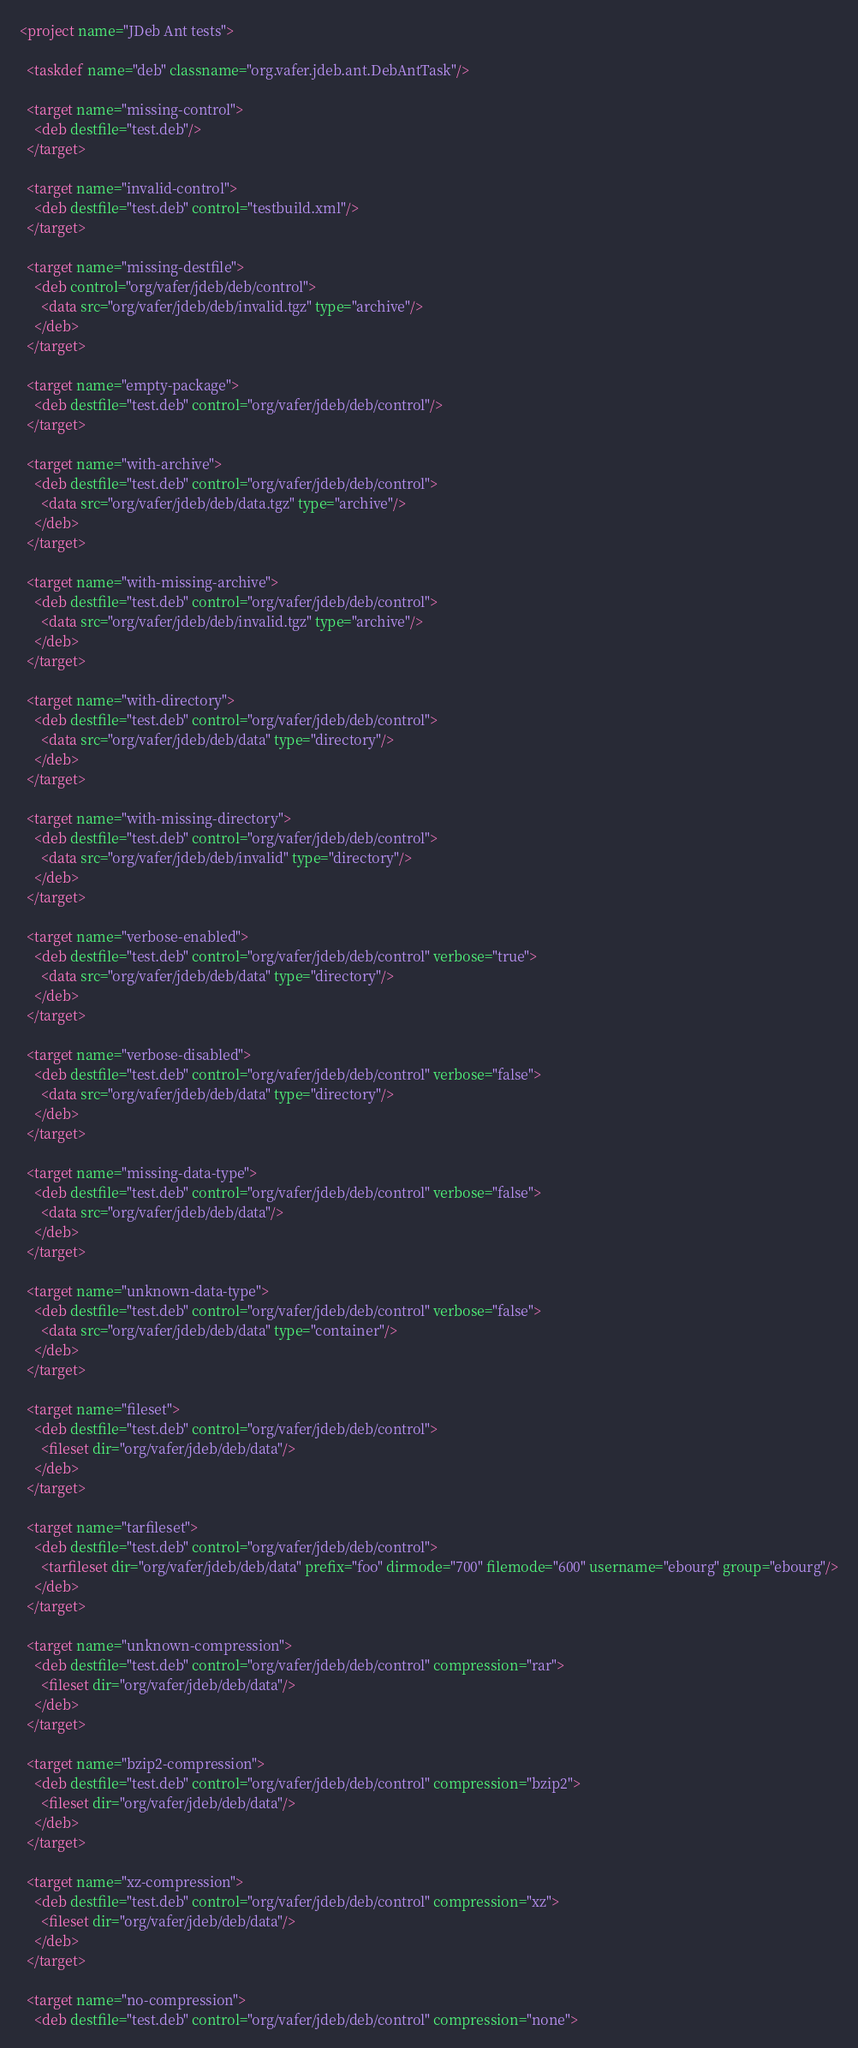Convert code to text. <code><loc_0><loc_0><loc_500><loc_500><_XML_><project name="JDeb Ant tests">

  <taskdef name="deb" classname="org.vafer.jdeb.ant.DebAntTask"/>

  <target name="missing-control">
    <deb destfile="test.deb"/>
  </target>

  <target name="invalid-control">
    <deb destfile="test.deb" control="testbuild.xml"/>
  </target>

  <target name="missing-destfile">
    <deb control="org/vafer/jdeb/deb/control">
      <data src="org/vafer/jdeb/deb/invalid.tgz" type="archive"/>
    </deb>
  </target>

  <target name="empty-package">
    <deb destfile="test.deb" control="org/vafer/jdeb/deb/control"/>
  </target>

  <target name="with-archive">
    <deb destfile="test.deb" control="org/vafer/jdeb/deb/control">
      <data src="org/vafer/jdeb/deb/data.tgz" type="archive"/>
    </deb>
  </target>

  <target name="with-missing-archive">
    <deb destfile="test.deb" control="org/vafer/jdeb/deb/control">
      <data src="org/vafer/jdeb/deb/invalid.tgz" type="archive"/>
    </deb>
  </target>

  <target name="with-directory">
    <deb destfile="test.deb" control="org/vafer/jdeb/deb/control">
      <data src="org/vafer/jdeb/deb/data" type="directory"/>
    </deb>
  </target>

  <target name="with-missing-directory">
    <deb destfile="test.deb" control="org/vafer/jdeb/deb/control">
      <data src="org/vafer/jdeb/deb/invalid" type="directory"/>
    </deb>
  </target>

  <target name="verbose-enabled">
    <deb destfile="test.deb" control="org/vafer/jdeb/deb/control" verbose="true">
      <data src="org/vafer/jdeb/deb/data" type="directory"/>
    </deb>
  </target>

  <target name="verbose-disabled">
    <deb destfile="test.deb" control="org/vafer/jdeb/deb/control" verbose="false">
      <data src="org/vafer/jdeb/deb/data" type="directory"/>
    </deb>
  </target>

  <target name="missing-data-type">
    <deb destfile="test.deb" control="org/vafer/jdeb/deb/control" verbose="false">
      <data src="org/vafer/jdeb/deb/data"/>
    </deb>
  </target>

  <target name="unknown-data-type">
    <deb destfile="test.deb" control="org/vafer/jdeb/deb/control" verbose="false">
      <data src="org/vafer/jdeb/deb/data" type="container"/>
    </deb>
  </target>

  <target name="fileset">
    <deb destfile="test.deb" control="org/vafer/jdeb/deb/control">
      <fileset dir="org/vafer/jdeb/deb/data"/>
    </deb>
  </target>

  <target name="tarfileset">
    <deb destfile="test.deb" control="org/vafer/jdeb/deb/control">
      <tarfileset dir="org/vafer/jdeb/deb/data" prefix="foo" dirmode="700" filemode="600" username="ebourg" group="ebourg"/>
    </deb>
  </target>

  <target name="unknown-compression">
    <deb destfile="test.deb" control="org/vafer/jdeb/deb/control" compression="rar">
      <fileset dir="org/vafer/jdeb/deb/data"/>
    </deb>
  </target>

  <target name="bzip2-compression">
    <deb destfile="test.deb" control="org/vafer/jdeb/deb/control" compression="bzip2">
      <fileset dir="org/vafer/jdeb/deb/data"/>
    </deb>
  </target>

  <target name="xz-compression">
    <deb destfile="test.deb" control="org/vafer/jdeb/deb/control" compression="xz">
      <fileset dir="org/vafer/jdeb/deb/data"/>
    </deb>
  </target>

  <target name="no-compression">
    <deb destfile="test.deb" control="org/vafer/jdeb/deb/control" compression="none"></code> 